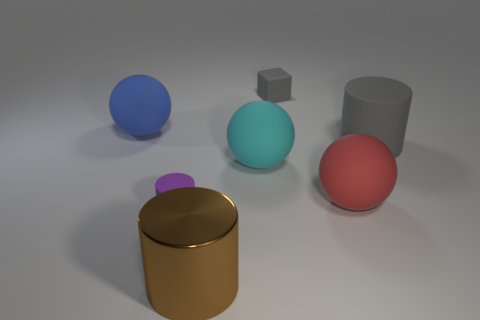Subtract all brown balls. Subtract all red cubes. How many balls are left? 3 Add 1 large cyan rubber objects. How many objects exist? 8 Subtract all balls. How many objects are left? 4 Add 2 cyan shiny objects. How many cyan shiny objects exist? 2 Subtract 1 red balls. How many objects are left? 6 Subtract all large metal objects. Subtract all small gray objects. How many objects are left? 5 Add 3 big matte cylinders. How many big matte cylinders are left? 4 